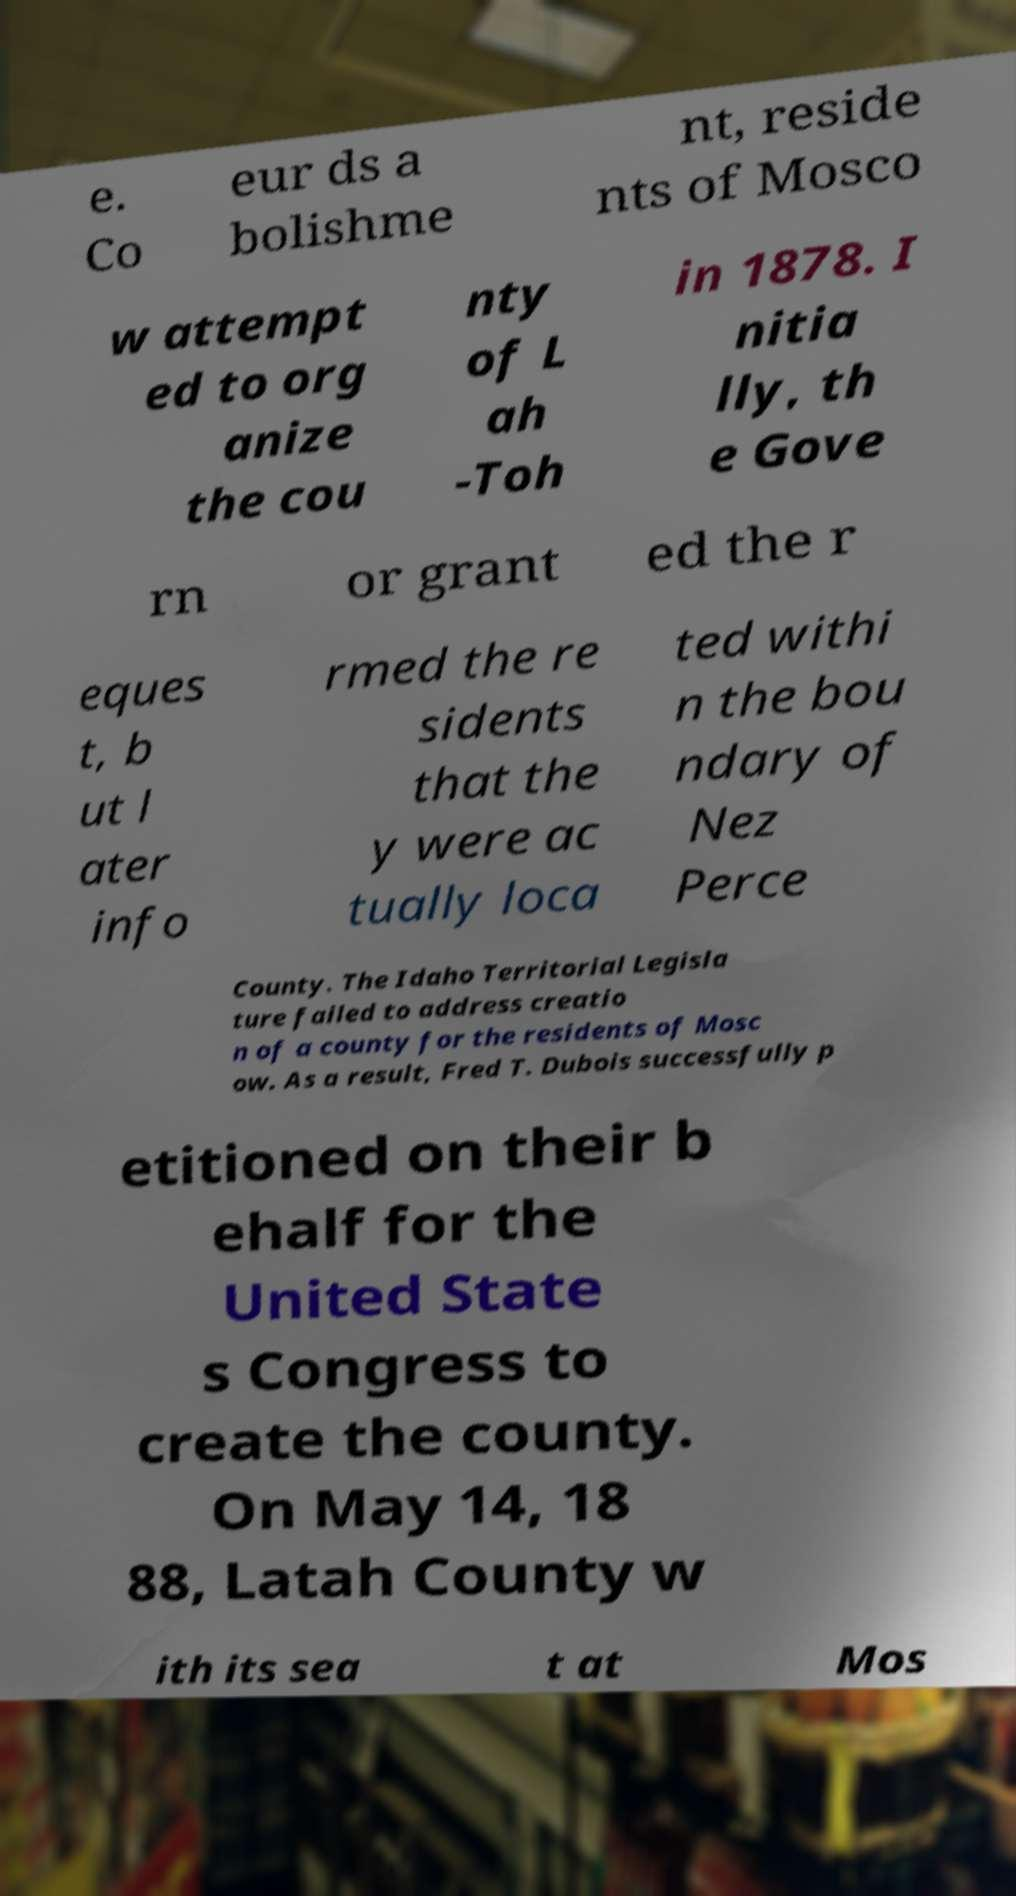Could you assist in decoding the text presented in this image and type it out clearly? e. Co eur ds a bolishme nt, reside nts of Mosco w attempt ed to org anize the cou nty of L ah -Toh in 1878. I nitia lly, th e Gove rn or grant ed the r eques t, b ut l ater info rmed the re sidents that the y were ac tually loca ted withi n the bou ndary of Nez Perce County. The Idaho Territorial Legisla ture failed to address creatio n of a county for the residents of Mosc ow. As a result, Fred T. Dubois successfully p etitioned on their b ehalf for the United State s Congress to create the county. On May 14, 18 88, Latah County w ith its sea t at Mos 